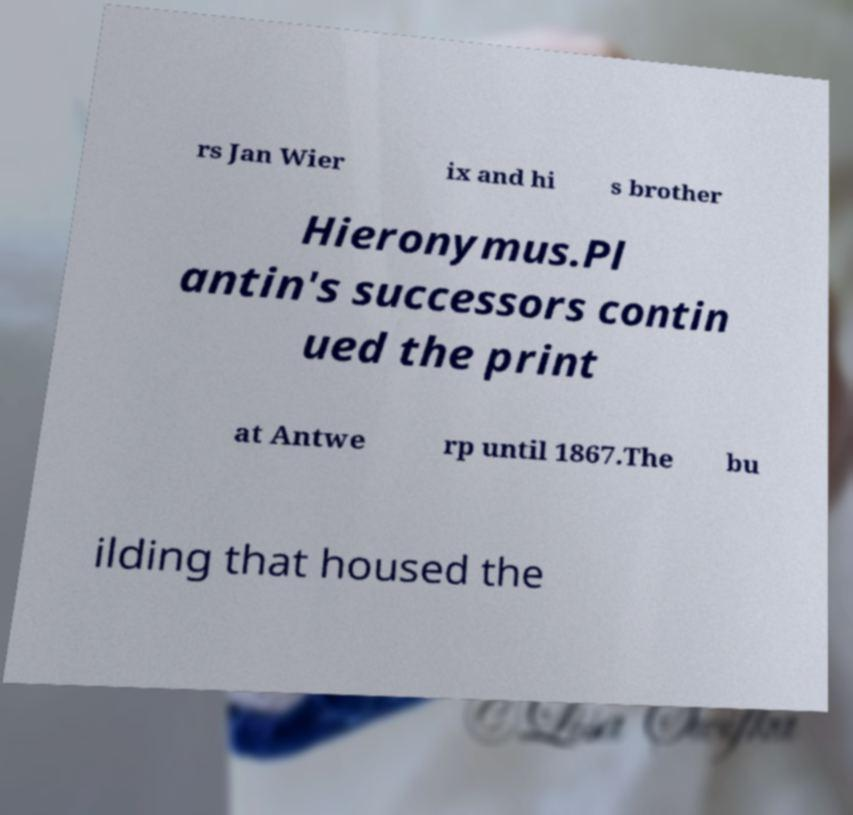Can you read and provide the text displayed in the image?This photo seems to have some interesting text. Can you extract and type it out for me? rs Jan Wier ix and hi s brother Hieronymus.Pl antin's successors contin ued the print at Antwe rp until 1867.The bu ilding that housed the 